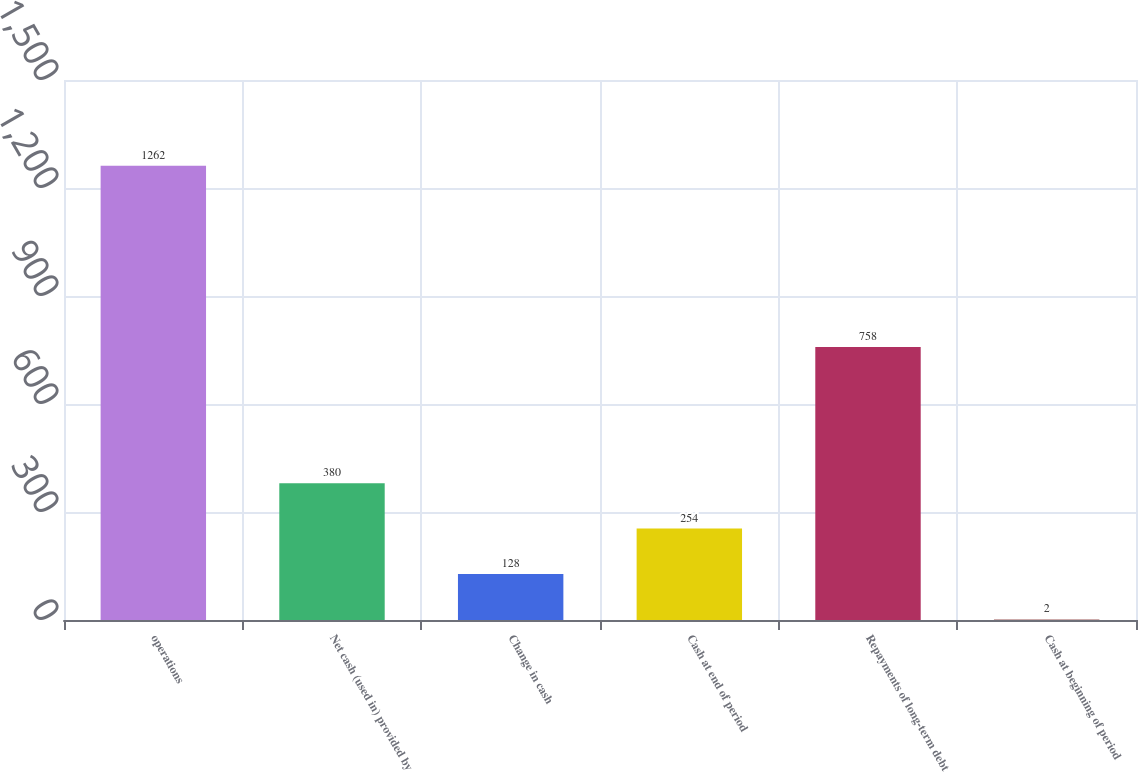Convert chart. <chart><loc_0><loc_0><loc_500><loc_500><bar_chart><fcel>operations<fcel>Net cash (used in) provided by<fcel>Change in cash<fcel>Cash at end of period<fcel>Repayments of long-term debt<fcel>Cash at beginning of period<nl><fcel>1262<fcel>380<fcel>128<fcel>254<fcel>758<fcel>2<nl></chart> 